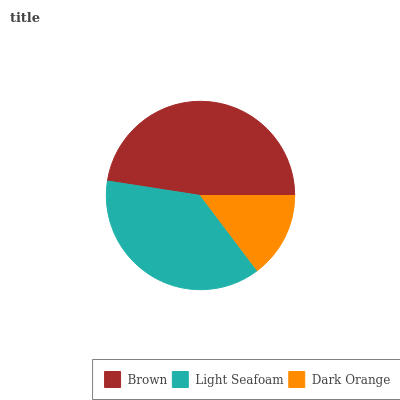Is Dark Orange the minimum?
Answer yes or no. Yes. Is Brown the maximum?
Answer yes or no. Yes. Is Light Seafoam the minimum?
Answer yes or no. No. Is Light Seafoam the maximum?
Answer yes or no. No. Is Brown greater than Light Seafoam?
Answer yes or no. Yes. Is Light Seafoam less than Brown?
Answer yes or no. Yes. Is Light Seafoam greater than Brown?
Answer yes or no. No. Is Brown less than Light Seafoam?
Answer yes or no. No. Is Light Seafoam the high median?
Answer yes or no. Yes. Is Light Seafoam the low median?
Answer yes or no. Yes. Is Dark Orange the high median?
Answer yes or no. No. Is Brown the low median?
Answer yes or no. No. 